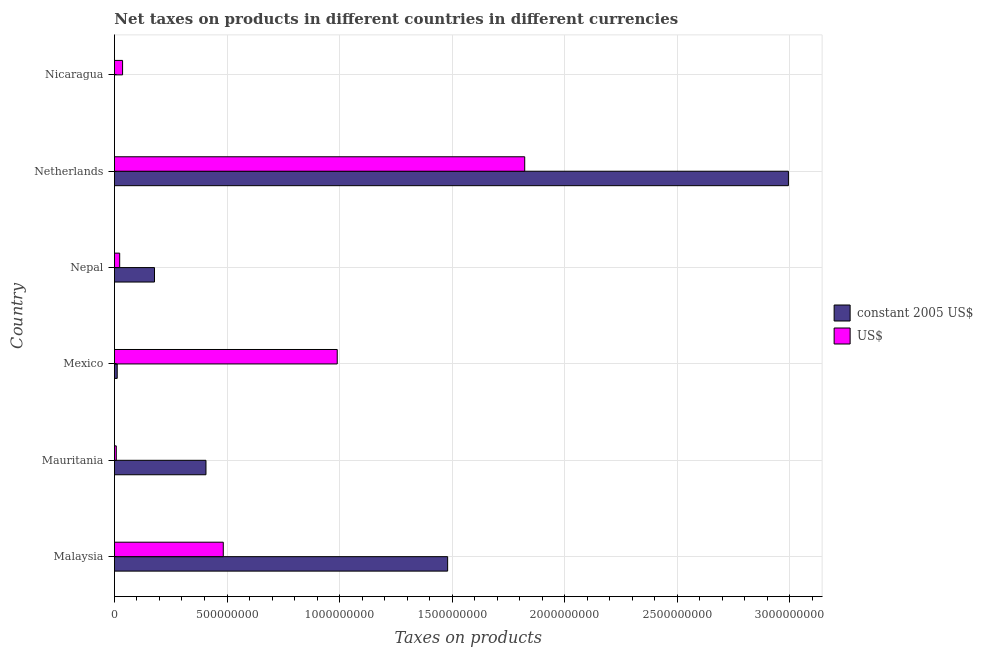How many groups of bars are there?
Offer a very short reply. 6. Are the number of bars per tick equal to the number of legend labels?
Provide a short and direct response. Yes. What is the label of the 3rd group of bars from the top?
Your response must be concise. Nepal. What is the net taxes in us$ in Malaysia?
Your response must be concise. 4.83e+08. Across all countries, what is the maximum net taxes in constant 2005 us$?
Make the answer very short. 2.99e+09. Across all countries, what is the minimum net taxes in constant 2005 us$?
Offer a terse response. 0.05. In which country was the net taxes in us$ minimum?
Provide a short and direct response. Mauritania. What is the total net taxes in us$ in the graph?
Offer a very short reply. 3.36e+09. What is the difference between the net taxes in us$ in Nepal and that in Nicaragua?
Give a very brief answer. -1.28e+07. What is the difference between the net taxes in us$ in Nepal and the net taxes in constant 2005 us$ in Mauritania?
Keep it short and to the point. -3.83e+08. What is the average net taxes in us$ per country?
Offer a very short reply. 5.61e+08. What is the difference between the net taxes in us$ and net taxes in constant 2005 us$ in Netherlands?
Offer a terse response. -1.17e+09. What is the ratio of the net taxes in us$ in Mauritania to that in Nicaragua?
Offer a terse response. 0.23. Is the net taxes in constant 2005 us$ in Malaysia less than that in Mexico?
Keep it short and to the point. No. Is the difference between the net taxes in us$ in Mexico and Nepal greater than the difference between the net taxes in constant 2005 us$ in Mexico and Nepal?
Offer a very short reply. Yes. What is the difference between the highest and the second highest net taxes in us$?
Provide a short and direct response. 8.33e+08. What is the difference between the highest and the lowest net taxes in constant 2005 us$?
Your answer should be compact. 2.99e+09. Is the sum of the net taxes in constant 2005 us$ in Mauritania and Nicaragua greater than the maximum net taxes in us$ across all countries?
Provide a short and direct response. No. What does the 2nd bar from the top in Mexico represents?
Offer a very short reply. Constant 2005 us$. What does the 2nd bar from the bottom in Mauritania represents?
Make the answer very short. US$. Are all the bars in the graph horizontal?
Provide a short and direct response. Yes. How many countries are there in the graph?
Provide a succinct answer. 6. What is the difference between two consecutive major ticks on the X-axis?
Give a very brief answer. 5.00e+08. What is the title of the graph?
Make the answer very short. Net taxes on products in different countries in different currencies. What is the label or title of the X-axis?
Ensure brevity in your answer.  Taxes on products. What is the Taxes on products of constant 2005 US$ in Malaysia?
Your answer should be very brief. 1.48e+09. What is the Taxes on products of US$ in Malaysia?
Keep it short and to the point. 4.83e+08. What is the Taxes on products in constant 2005 US$ in Mauritania?
Your answer should be very brief. 4.07e+08. What is the Taxes on products of US$ in Mauritania?
Keep it short and to the point. 8.24e+06. What is the Taxes on products of constant 2005 US$ in Mexico?
Your answer should be compact. 1.24e+07. What is the Taxes on products of US$ in Mexico?
Offer a terse response. 9.90e+08. What is the Taxes on products of constant 2005 US$ in Nepal?
Offer a very short reply. 1.78e+08. What is the Taxes on products in US$ in Nepal?
Give a very brief answer. 2.34e+07. What is the Taxes on products of constant 2005 US$ in Netherlands?
Offer a very short reply. 2.99e+09. What is the Taxes on products in US$ in Netherlands?
Your response must be concise. 1.82e+09. What is the Taxes on products of constant 2005 US$ in Nicaragua?
Provide a short and direct response. 0.05. What is the Taxes on products in US$ in Nicaragua?
Offer a very short reply. 3.62e+07. Across all countries, what is the maximum Taxes on products of constant 2005 US$?
Offer a very short reply. 2.99e+09. Across all countries, what is the maximum Taxes on products in US$?
Make the answer very short. 1.82e+09. Across all countries, what is the minimum Taxes on products of constant 2005 US$?
Give a very brief answer. 0.05. Across all countries, what is the minimum Taxes on products in US$?
Keep it short and to the point. 8.24e+06. What is the total Taxes on products in constant 2005 US$ in the graph?
Ensure brevity in your answer.  5.07e+09. What is the total Taxes on products of US$ in the graph?
Offer a very short reply. 3.36e+09. What is the difference between the Taxes on products of constant 2005 US$ in Malaysia and that in Mauritania?
Make the answer very short. 1.07e+09. What is the difference between the Taxes on products of US$ in Malaysia and that in Mauritania?
Your answer should be very brief. 4.75e+08. What is the difference between the Taxes on products in constant 2005 US$ in Malaysia and that in Mexico?
Offer a very short reply. 1.47e+09. What is the difference between the Taxes on products of US$ in Malaysia and that in Mexico?
Give a very brief answer. -5.06e+08. What is the difference between the Taxes on products of constant 2005 US$ in Malaysia and that in Nepal?
Keep it short and to the point. 1.30e+09. What is the difference between the Taxes on products in US$ in Malaysia and that in Nepal?
Your answer should be very brief. 4.60e+08. What is the difference between the Taxes on products in constant 2005 US$ in Malaysia and that in Netherlands?
Your answer should be very brief. -1.51e+09. What is the difference between the Taxes on products of US$ in Malaysia and that in Netherlands?
Your response must be concise. -1.34e+09. What is the difference between the Taxes on products of constant 2005 US$ in Malaysia and that in Nicaragua?
Offer a terse response. 1.48e+09. What is the difference between the Taxes on products of US$ in Malaysia and that in Nicaragua?
Make the answer very short. 4.47e+08. What is the difference between the Taxes on products of constant 2005 US$ in Mauritania and that in Mexico?
Offer a very short reply. 3.94e+08. What is the difference between the Taxes on products of US$ in Mauritania and that in Mexico?
Ensure brevity in your answer.  -9.81e+08. What is the difference between the Taxes on products in constant 2005 US$ in Mauritania and that in Nepal?
Give a very brief answer. 2.29e+08. What is the difference between the Taxes on products of US$ in Mauritania and that in Nepal?
Keep it short and to the point. -1.51e+07. What is the difference between the Taxes on products in constant 2005 US$ in Mauritania and that in Netherlands?
Your response must be concise. -2.59e+09. What is the difference between the Taxes on products of US$ in Mauritania and that in Netherlands?
Offer a very short reply. -1.81e+09. What is the difference between the Taxes on products in constant 2005 US$ in Mauritania and that in Nicaragua?
Keep it short and to the point. 4.07e+08. What is the difference between the Taxes on products of US$ in Mauritania and that in Nicaragua?
Make the answer very short. -2.80e+07. What is the difference between the Taxes on products of constant 2005 US$ in Mexico and that in Nepal?
Provide a succinct answer. -1.66e+08. What is the difference between the Taxes on products of US$ in Mexico and that in Nepal?
Your answer should be compact. 9.66e+08. What is the difference between the Taxes on products in constant 2005 US$ in Mexico and that in Netherlands?
Your answer should be very brief. -2.98e+09. What is the difference between the Taxes on products of US$ in Mexico and that in Netherlands?
Your answer should be compact. -8.33e+08. What is the difference between the Taxes on products in constant 2005 US$ in Mexico and that in Nicaragua?
Provide a short and direct response. 1.24e+07. What is the difference between the Taxes on products of US$ in Mexico and that in Nicaragua?
Keep it short and to the point. 9.53e+08. What is the difference between the Taxes on products of constant 2005 US$ in Nepal and that in Netherlands?
Your answer should be compact. -2.82e+09. What is the difference between the Taxes on products in US$ in Nepal and that in Netherlands?
Your answer should be compact. -1.80e+09. What is the difference between the Taxes on products in constant 2005 US$ in Nepal and that in Nicaragua?
Give a very brief answer. 1.78e+08. What is the difference between the Taxes on products of US$ in Nepal and that in Nicaragua?
Ensure brevity in your answer.  -1.28e+07. What is the difference between the Taxes on products of constant 2005 US$ in Netherlands and that in Nicaragua?
Ensure brevity in your answer.  2.99e+09. What is the difference between the Taxes on products of US$ in Netherlands and that in Nicaragua?
Your answer should be very brief. 1.79e+09. What is the difference between the Taxes on products in constant 2005 US$ in Malaysia and the Taxes on products in US$ in Mauritania?
Provide a succinct answer. 1.47e+09. What is the difference between the Taxes on products of constant 2005 US$ in Malaysia and the Taxes on products of US$ in Mexico?
Give a very brief answer. 4.90e+08. What is the difference between the Taxes on products of constant 2005 US$ in Malaysia and the Taxes on products of US$ in Nepal?
Provide a short and direct response. 1.46e+09. What is the difference between the Taxes on products of constant 2005 US$ in Malaysia and the Taxes on products of US$ in Netherlands?
Ensure brevity in your answer.  -3.42e+08. What is the difference between the Taxes on products in constant 2005 US$ in Malaysia and the Taxes on products in US$ in Nicaragua?
Offer a very short reply. 1.44e+09. What is the difference between the Taxes on products in constant 2005 US$ in Mauritania and the Taxes on products in US$ in Mexico?
Your answer should be very brief. -5.83e+08. What is the difference between the Taxes on products in constant 2005 US$ in Mauritania and the Taxes on products in US$ in Nepal?
Make the answer very short. 3.83e+08. What is the difference between the Taxes on products of constant 2005 US$ in Mauritania and the Taxes on products of US$ in Netherlands?
Provide a short and direct response. -1.42e+09. What is the difference between the Taxes on products of constant 2005 US$ in Mauritania and the Taxes on products of US$ in Nicaragua?
Offer a very short reply. 3.70e+08. What is the difference between the Taxes on products in constant 2005 US$ in Mexico and the Taxes on products in US$ in Nepal?
Offer a very short reply. -1.10e+07. What is the difference between the Taxes on products in constant 2005 US$ in Mexico and the Taxes on products in US$ in Netherlands?
Offer a terse response. -1.81e+09. What is the difference between the Taxes on products of constant 2005 US$ in Mexico and the Taxes on products of US$ in Nicaragua?
Offer a very short reply. -2.38e+07. What is the difference between the Taxes on products in constant 2005 US$ in Nepal and the Taxes on products in US$ in Netherlands?
Provide a succinct answer. -1.64e+09. What is the difference between the Taxes on products in constant 2005 US$ in Nepal and the Taxes on products in US$ in Nicaragua?
Provide a succinct answer. 1.42e+08. What is the difference between the Taxes on products of constant 2005 US$ in Netherlands and the Taxes on products of US$ in Nicaragua?
Make the answer very short. 2.96e+09. What is the average Taxes on products in constant 2005 US$ per country?
Provide a short and direct response. 8.45e+08. What is the average Taxes on products of US$ per country?
Provide a short and direct response. 5.61e+08. What is the difference between the Taxes on products in constant 2005 US$ and Taxes on products in US$ in Malaysia?
Provide a short and direct response. 9.97e+08. What is the difference between the Taxes on products in constant 2005 US$ and Taxes on products in US$ in Mauritania?
Your answer should be compact. 3.98e+08. What is the difference between the Taxes on products of constant 2005 US$ and Taxes on products of US$ in Mexico?
Provide a succinct answer. -9.77e+08. What is the difference between the Taxes on products of constant 2005 US$ and Taxes on products of US$ in Nepal?
Keep it short and to the point. 1.55e+08. What is the difference between the Taxes on products in constant 2005 US$ and Taxes on products in US$ in Netherlands?
Give a very brief answer. 1.17e+09. What is the difference between the Taxes on products of constant 2005 US$ and Taxes on products of US$ in Nicaragua?
Make the answer very short. -3.62e+07. What is the ratio of the Taxes on products of constant 2005 US$ in Malaysia to that in Mauritania?
Provide a succinct answer. 3.64. What is the ratio of the Taxes on products in US$ in Malaysia to that in Mauritania?
Your answer should be very brief. 58.7. What is the ratio of the Taxes on products in constant 2005 US$ in Malaysia to that in Mexico?
Provide a succinct answer. 119.64. What is the ratio of the Taxes on products in US$ in Malaysia to that in Mexico?
Offer a terse response. 0.49. What is the ratio of the Taxes on products of constant 2005 US$ in Malaysia to that in Nepal?
Ensure brevity in your answer.  8.31. What is the ratio of the Taxes on products in US$ in Malaysia to that in Nepal?
Your response must be concise. 20.69. What is the ratio of the Taxes on products of constant 2005 US$ in Malaysia to that in Netherlands?
Make the answer very short. 0.49. What is the ratio of the Taxes on products in US$ in Malaysia to that in Netherlands?
Ensure brevity in your answer.  0.27. What is the ratio of the Taxes on products in constant 2005 US$ in Malaysia to that in Nicaragua?
Your answer should be very brief. 2.92e+1. What is the ratio of the Taxes on products of US$ in Malaysia to that in Nicaragua?
Offer a terse response. 13.35. What is the ratio of the Taxes on products in constant 2005 US$ in Mauritania to that in Mexico?
Keep it short and to the point. 32.87. What is the ratio of the Taxes on products of US$ in Mauritania to that in Mexico?
Offer a terse response. 0.01. What is the ratio of the Taxes on products in constant 2005 US$ in Mauritania to that in Nepal?
Offer a terse response. 2.28. What is the ratio of the Taxes on products of US$ in Mauritania to that in Nepal?
Provide a succinct answer. 0.35. What is the ratio of the Taxes on products of constant 2005 US$ in Mauritania to that in Netherlands?
Provide a succinct answer. 0.14. What is the ratio of the Taxes on products in US$ in Mauritania to that in Netherlands?
Your answer should be compact. 0. What is the ratio of the Taxes on products of constant 2005 US$ in Mauritania to that in Nicaragua?
Provide a succinct answer. 8.03e+09. What is the ratio of the Taxes on products of US$ in Mauritania to that in Nicaragua?
Give a very brief answer. 0.23. What is the ratio of the Taxes on products of constant 2005 US$ in Mexico to that in Nepal?
Offer a very short reply. 0.07. What is the ratio of the Taxes on products in US$ in Mexico to that in Nepal?
Offer a very short reply. 42.36. What is the ratio of the Taxes on products of constant 2005 US$ in Mexico to that in Netherlands?
Make the answer very short. 0. What is the ratio of the Taxes on products of US$ in Mexico to that in Netherlands?
Keep it short and to the point. 0.54. What is the ratio of the Taxes on products in constant 2005 US$ in Mexico to that in Nicaragua?
Offer a terse response. 2.44e+08. What is the ratio of the Taxes on products of US$ in Mexico to that in Nicaragua?
Offer a very short reply. 27.33. What is the ratio of the Taxes on products in constant 2005 US$ in Nepal to that in Netherlands?
Offer a very short reply. 0.06. What is the ratio of the Taxes on products of US$ in Nepal to that in Netherlands?
Offer a terse response. 0.01. What is the ratio of the Taxes on products in constant 2005 US$ in Nepal to that in Nicaragua?
Offer a very short reply. 3.51e+09. What is the ratio of the Taxes on products in US$ in Nepal to that in Nicaragua?
Make the answer very short. 0.65. What is the ratio of the Taxes on products of constant 2005 US$ in Netherlands to that in Nicaragua?
Offer a very short reply. 5.91e+1. What is the ratio of the Taxes on products of US$ in Netherlands to that in Nicaragua?
Make the answer very short. 50.34. What is the difference between the highest and the second highest Taxes on products of constant 2005 US$?
Give a very brief answer. 1.51e+09. What is the difference between the highest and the second highest Taxes on products in US$?
Your answer should be very brief. 8.33e+08. What is the difference between the highest and the lowest Taxes on products in constant 2005 US$?
Ensure brevity in your answer.  2.99e+09. What is the difference between the highest and the lowest Taxes on products of US$?
Offer a terse response. 1.81e+09. 